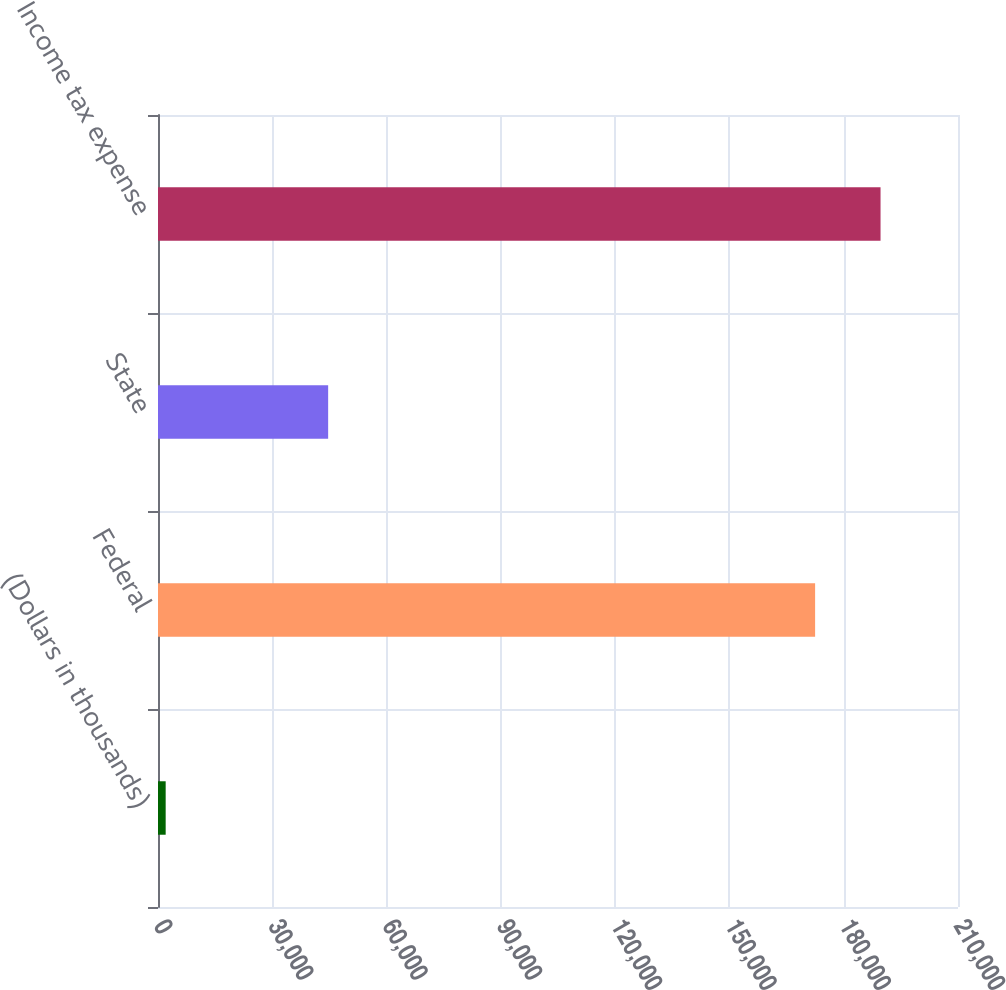Convert chart to OTSL. <chart><loc_0><loc_0><loc_500><loc_500><bar_chart><fcel>(Dollars in thousands)<fcel>Federal<fcel>State<fcel>Income tax expense<nl><fcel>2014<fcel>172492<fcel>44666<fcel>189667<nl></chart> 